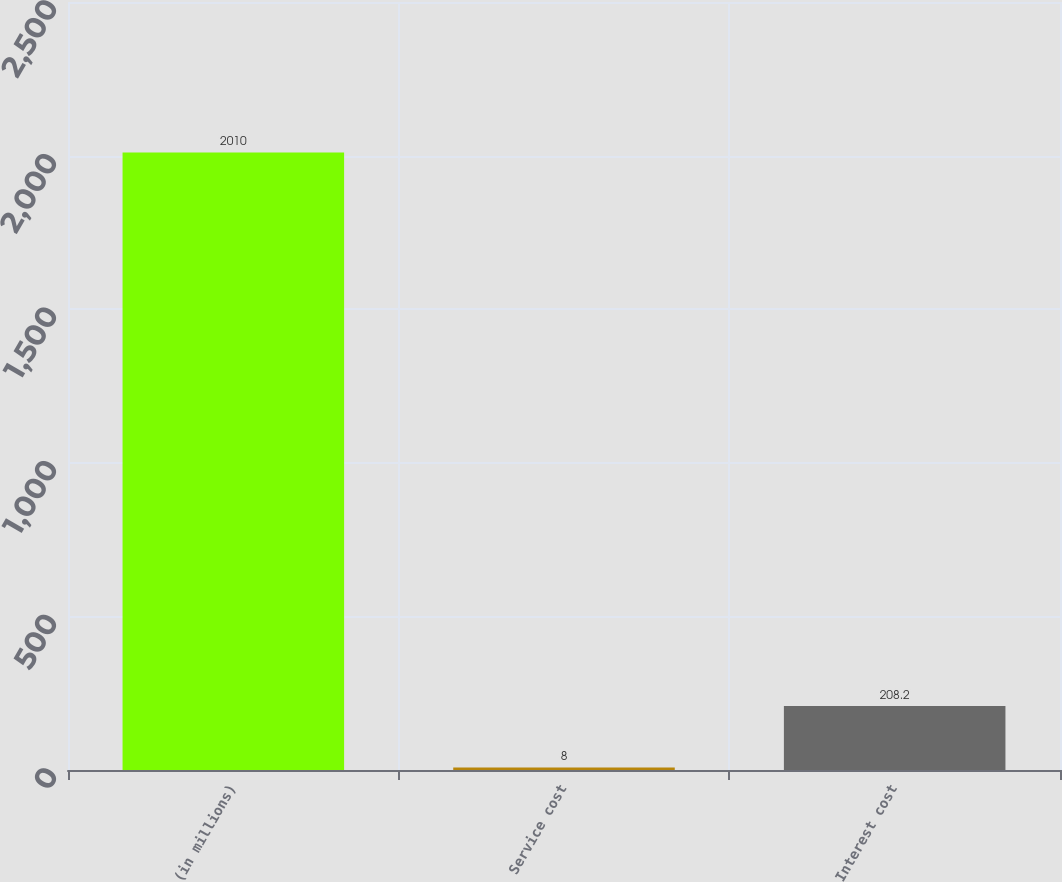Convert chart. <chart><loc_0><loc_0><loc_500><loc_500><bar_chart><fcel>(in millions)<fcel>Service cost<fcel>Interest cost<nl><fcel>2010<fcel>8<fcel>208.2<nl></chart> 